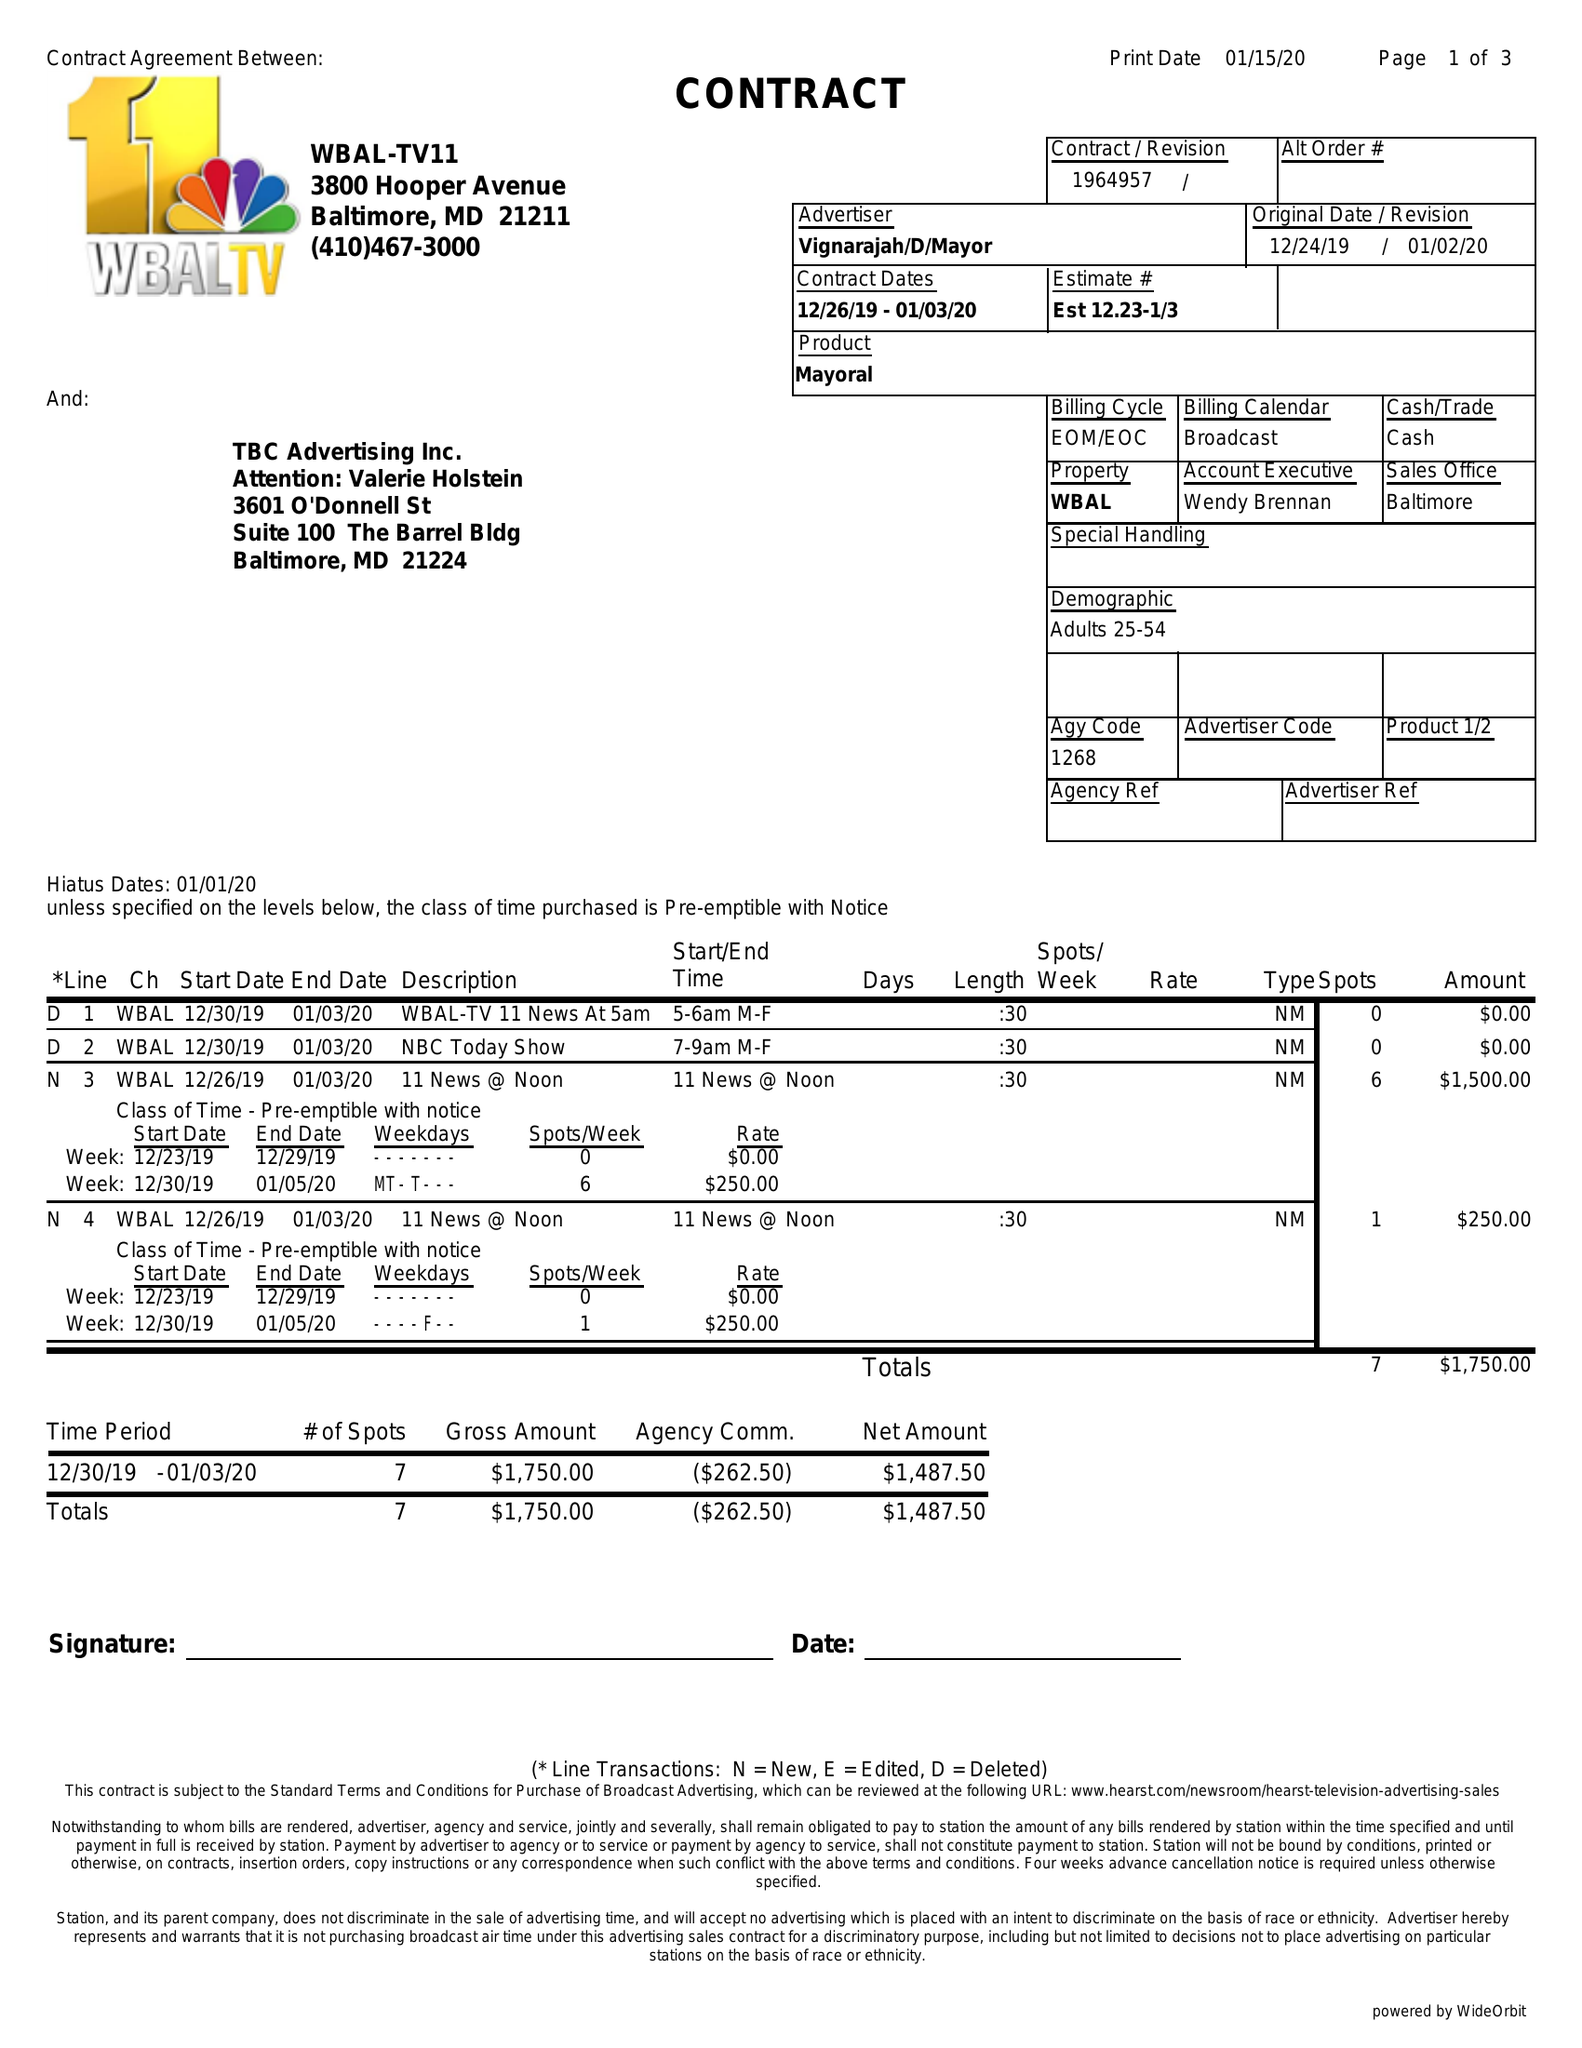What is the value for the flight_from?
Answer the question using a single word or phrase. 12/26/19 